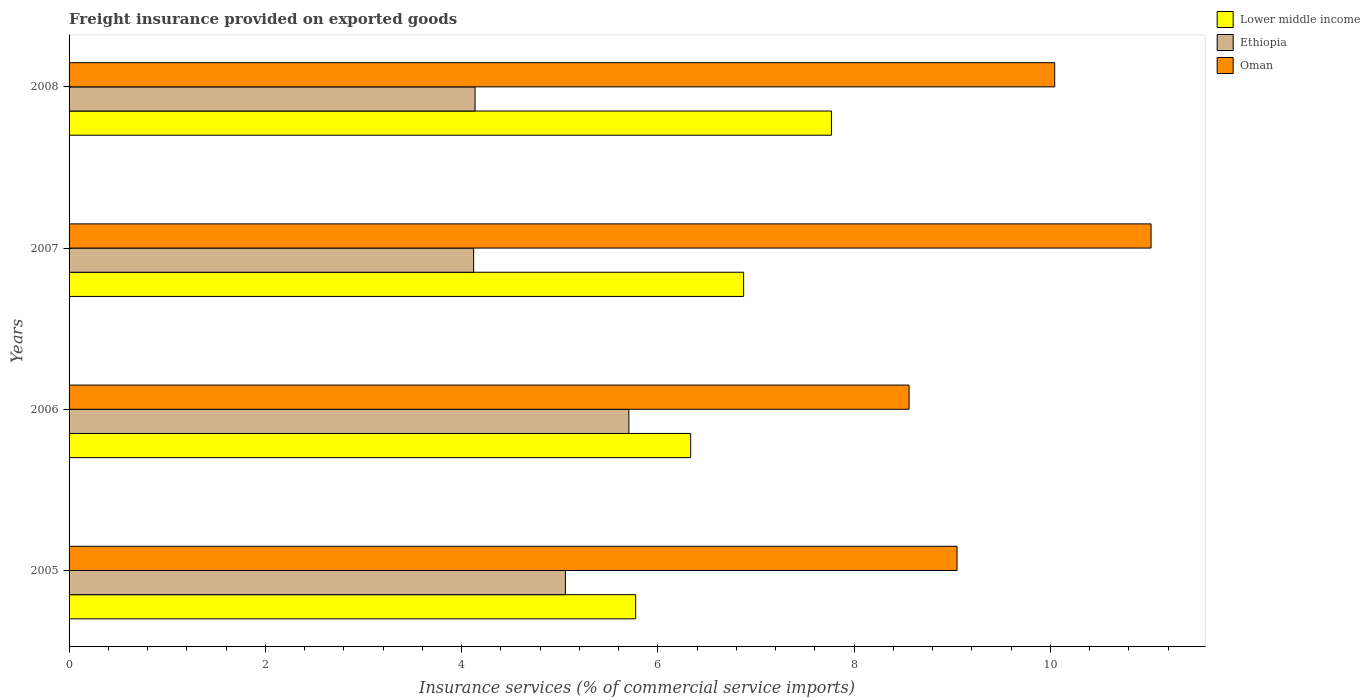Are the number of bars per tick equal to the number of legend labels?
Your answer should be compact. Yes. Are the number of bars on each tick of the Y-axis equal?
Ensure brevity in your answer.  Yes. How many bars are there on the 2nd tick from the top?
Ensure brevity in your answer.  3. What is the label of the 3rd group of bars from the top?
Provide a short and direct response. 2006. What is the freight insurance provided on exported goods in Lower middle income in 2007?
Make the answer very short. 6.87. Across all years, what is the maximum freight insurance provided on exported goods in Ethiopia?
Your response must be concise. 5.7. Across all years, what is the minimum freight insurance provided on exported goods in Ethiopia?
Offer a very short reply. 4.12. What is the total freight insurance provided on exported goods in Lower middle income in the graph?
Give a very brief answer. 26.75. What is the difference between the freight insurance provided on exported goods in Lower middle income in 2006 and that in 2007?
Provide a succinct answer. -0.54. What is the difference between the freight insurance provided on exported goods in Ethiopia in 2006 and the freight insurance provided on exported goods in Lower middle income in 2008?
Offer a terse response. -2.06. What is the average freight insurance provided on exported goods in Oman per year?
Provide a succinct answer. 9.67. In the year 2007, what is the difference between the freight insurance provided on exported goods in Ethiopia and freight insurance provided on exported goods in Oman?
Give a very brief answer. -6.9. What is the ratio of the freight insurance provided on exported goods in Ethiopia in 2007 to that in 2008?
Ensure brevity in your answer.  1. What is the difference between the highest and the second highest freight insurance provided on exported goods in Lower middle income?
Offer a terse response. 0.9. What is the difference between the highest and the lowest freight insurance provided on exported goods in Ethiopia?
Offer a very short reply. 1.58. In how many years, is the freight insurance provided on exported goods in Oman greater than the average freight insurance provided on exported goods in Oman taken over all years?
Keep it short and to the point. 2. What does the 3rd bar from the top in 2008 represents?
Offer a very short reply. Lower middle income. What does the 1st bar from the bottom in 2006 represents?
Give a very brief answer. Lower middle income. How many bars are there?
Give a very brief answer. 12. Are all the bars in the graph horizontal?
Offer a very short reply. Yes. What is the difference between two consecutive major ticks on the X-axis?
Keep it short and to the point. 2. Where does the legend appear in the graph?
Offer a terse response. Top right. How are the legend labels stacked?
Provide a succinct answer. Vertical. What is the title of the graph?
Offer a terse response. Freight insurance provided on exported goods. What is the label or title of the X-axis?
Offer a very short reply. Insurance services (% of commercial service imports). What is the Insurance services (% of commercial service imports) in Lower middle income in 2005?
Keep it short and to the point. 5.77. What is the Insurance services (% of commercial service imports) in Ethiopia in 2005?
Your answer should be compact. 5.06. What is the Insurance services (% of commercial service imports) in Oman in 2005?
Your response must be concise. 9.05. What is the Insurance services (% of commercial service imports) in Lower middle income in 2006?
Your response must be concise. 6.33. What is the Insurance services (% of commercial service imports) in Ethiopia in 2006?
Your response must be concise. 5.7. What is the Insurance services (% of commercial service imports) in Oman in 2006?
Offer a very short reply. 8.56. What is the Insurance services (% of commercial service imports) of Lower middle income in 2007?
Give a very brief answer. 6.87. What is the Insurance services (% of commercial service imports) of Ethiopia in 2007?
Your answer should be very brief. 4.12. What is the Insurance services (% of commercial service imports) of Oman in 2007?
Offer a terse response. 11.03. What is the Insurance services (% of commercial service imports) of Lower middle income in 2008?
Make the answer very short. 7.77. What is the Insurance services (% of commercial service imports) of Ethiopia in 2008?
Your answer should be very brief. 4.14. What is the Insurance services (% of commercial service imports) of Oman in 2008?
Offer a terse response. 10.04. Across all years, what is the maximum Insurance services (% of commercial service imports) in Lower middle income?
Offer a terse response. 7.77. Across all years, what is the maximum Insurance services (% of commercial service imports) in Ethiopia?
Your answer should be very brief. 5.7. Across all years, what is the maximum Insurance services (% of commercial service imports) of Oman?
Offer a very short reply. 11.03. Across all years, what is the minimum Insurance services (% of commercial service imports) of Lower middle income?
Give a very brief answer. 5.77. Across all years, what is the minimum Insurance services (% of commercial service imports) in Ethiopia?
Offer a terse response. 4.12. Across all years, what is the minimum Insurance services (% of commercial service imports) of Oman?
Provide a short and direct response. 8.56. What is the total Insurance services (% of commercial service imports) in Lower middle income in the graph?
Your answer should be very brief. 26.75. What is the total Insurance services (% of commercial service imports) in Ethiopia in the graph?
Your answer should be very brief. 19.02. What is the total Insurance services (% of commercial service imports) in Oman in the graph?
Provide a succinct answer. 38.68. What is the difference between the Insurance services (% of commercial service imports) of Lower middle income in 2005 and that in 2006?
Make the answer very short. -0.56. What is the difference between the Insurance services (% of commercial service imports) of Ethiopia in 2005 and that in 2006?
Your answer should be very brief. -0.65. What is the difference between the Insurance services (% of commercial service imports) in Oman in 2005 and that in 2006?
Your response must be concise. 0.49. What is the difference between the Insurance services (% of commercial service imports) of Lower middle income in 2005 and that in 2007?
Your answer should be compact. -1.1. What is the difference between the Insurance services (% of commercial service imports) in Ethiopia in 2005 and that in 2007?
Make the answer very short. 0.94. What is the difference between the Insurance services (% of commercial service imports) of Oman in 2005 and that in 2007?
Provide a succinct answer. -1.98. What is the difference between the Insurance services (% of commercial service imports) in Lower middle income in 2005 and that in 2008?
Provide a short and direct response. -2. What is the difference between the Insurance services (% of commercial service imports) of Ethiopia in 2005 and that in 2008?
Provide a succinct answer. 0.92. What is the difference between the Insurance services (% of commercial service imports) of Oman in 2005 and that in 2008?
Give a very brief answer. -1. What is the difference between the Insurance services (% of commercial service imports) of Lower middle income in 2006 and that in 2007?
Provide a short and direct response. -0.54. What is the difference between the Insurance services (% of commercial service imports) in Ethiopia in 2006 and that in 2007?
Give a very brief answer. 1.58. What is the difference between the Insurance services (% of commercial service imports) in Oman in 2006 and that in 2007?
Offer a terse response. -2.47. What is the difference between the Insurance services (% of commercial service imports) of Lower middle income in 2006 and that in 2008?
Offer a terse response. -1.43. What is the difference between the Insurance services (% of commercial service imports) in Ethiopia in 2006 and that in 2008?
Make the answer very short. 1.57. What is the difference between the Insurance services (% of commercial service imports) of Oman in 2006 and that in 2008?
Offer a terse response. -1.48. What is the difference between the Insurance services (% of commercial service imports) of Lower middle income in 2007 and that in 2008?
Provide a short and direct response. -0.9. What is the difference between the Insurance services (% of commercial service imports) of Ethiopia in 2007 and that in 2008?
Provide a succinct answer. -0.01. What is the difference between the Insurance services (% of commercial service imports) of Oman in 2007 and that in 2008?
Offer a terse response. 0.98. What is the difference between the Insurance services (% of commercial service imports) in Lower middle income in 2005 and the Insurance services (% of commercial service imports) in Ethiopia in 2006?
Keep it short and to the point. 0.07. What is the difference between the Insurance services (% of commercial service imports) of Lower middle income in 2005 and the Insurance services (% of commercial service imports) of Oman in 2006?
Your response must be concise. -2.79. What is the difference between the Insurance services (% of commercial service imports) of Ethiopia in 2005 and the Insurance services (% of commercial service imports) of Oman in 2006?
Offer a very short reply. -3.5. What is the difference between the Insurance services (% of commercial service imports) of Lower middle income in 2005 and the Insurance services (% of commercial service imports) of Ethiopia in 2007?
Make the answer very short. 1.65. What is the difference between the Insurance services (% of commercial service imports) in Lower middle income in 2005 and the Insurance services (% of commercial service imports) in Oman in 2007?
Your response must be concise. -5.25. What is the difference between the Insurance services (% of commercial service imports) of Ethiopia in 2005 and the Insurance services (% of commercial service imports) of Oman in 2007?
Your answer should be very brief. -5.97. What is the difference between the Insurance services (% of commercial service imports) of Lower middle income in 2005 and the Insurance services (% of commercial service imports) of Ethiopia in 2008?
Ensure brevity in your answer.  1.64. What is the difference between the Insurance services (% of commercial service imports) of Lower middle income in 2005 and the Insurance services (% of commercial service imports) of Oman in 2008?
Offer a very short reply. -4.27. What is the difference between the Insurance services (% of commercial service imports) in Ethiopia in 2005 and the Insurance services (% of commercial service imports) in Oman in 2008?
Offer a very short reply. -4.99. What is the difference between the Insurance services (% of commercial service imports) in Lower middle income in 2006 and the Insurance services (% of commercial service imports) in Ethiopia in 2007?
Make the answer very short. 2.21. What is the difference between the Insurance services (% of commercial service imports) in Lower middle income in 2006 and the Insurance services (% of commercial service imports) in Oman in 2007?
Give a very brief answer. -4.69. What is the difference between the Insurance services (% of commercial service imports) in Ethiopia in 2006 and the Insurance services (% of commercial service imports) in Oman in 2007?
Your response must be concise. -5.32. What is the difference between the Insurance services (% of commercial service imports) of Lower middle income in 2006 and the Insurance services (% of commercial service imports) of Ethiopia in 2008?
Give a very brief answer. 2.2. What is the difference between the Insurance services (% of commercial service imports) in Lower middle income in 2006 and the Insurance services (% of commercial service imports) in Oman in 2008?
Offer a terse response. -3.71. What is the difference between the Insurance services (% of commercial service imports) in Ethiopia in 2006 and the Insurance services (% of commercial service imports) in Oman in 2008?
Your answer should be very brief. -4.34. What is the difference between the Insurance services (% of commercial service imports) in Lower middle income in 2007 and the Insurance services (% of commercial service imports) in Ethiopia in 2008?
Offer a very short reply. 2.74. What is the difference between the Insurance services (% of commercial service imports) in Lower middle income in 2007 and the Insurance services (% of commercial service imports) in Oman in 2008?
Offer a very short reply. -3.17. What is the difference between the Insurance services (% of commercial service imports) in Ethiopia in 2007 and the Insurance services (% of commercial service imports) in Oman in 2008?
Your answer should be very brief. -5.92. What is the average Insurance services (% of commercial service imports) of Lower middle income per year?
Your response must be concise. 6.69. What is the average Insurance services (% of commercial service imports) of Ethiopia per year?
Offer a terse response. 4.76. What is the average Insurance services (% of commercial service imports) in Oman per year?
Your answer should be very brief. 9.67. In the year 2005, what is the difference between the Insurance services (% of commercial service imports) in Lower middle income and Insurance services (% of commercial service imports) in Ethiopia?
Provide a succinct answer. 0.72. In the year 2005, what is the difference between the Insurance services (% of commercial service imports) of Lower middle income and Insurance services (% of commercial service imports) of Oman?
Offer a very short reply. -3.27. In the year 2005, what is the difference between the Insurance services (% of commercial service imports) of Ethiopia and Insurance services (% of commercial service imports) of Oman?
Keep it short and to the point. -3.99. In the year 2006, what is the difference between the Insurance services (% of commercial service imports) of Lower middle income and Insurance services (% of commercial service imports) of Ethiopia?
Your answer should be very brief. 0.63. In the year 2006, what is the difference between the Insurance services (% of commercial service imports) in Lower middle income and Insurance services (% of commercial service imports) in Oman?
Keep it short and to the point. -2.23. In the year 2006, what is the difference between the Insurance services (% of commercial service imports) of Ethiopia and Insurance services (% of commercial service imports) of Oman?
Make the answer very short. -2.86. In the year 2007, what is the difference between the Insurance services (% of commercial service imports) of Lower middle income and Insurance services (% of commercial service imports) of Ethiopia?
Your answer should be very brief. 2.75. In the year 2007, what is the difference between the Insurance services (% of commercial service imports) of Lower middle income and Insurance services (% of commercial service imports) of Oman?
Offer a very short reply. -4.15. In the year 2007, what is the difference between the Insurance services (% of commercial service imports) of Ethiopia and Insurance services (% of commercial service imports) of Oman?
Provide a short and direct response. -6.9. In the year 2008, what is the difference between the Insurance services (% of commercial service imports) of Lower middle income and Insurance services (% of commercial service imports) of Ethiopia?
Keep it short and to the point. 3.63. In the year 2008, what is the difference between the Insurance services (% of commercial service imports) in Lower middle income and Insurance services (% of commercial service imports) in Oman?
Offer a very short reply. -2.28. In the year 2008, what is the difference between the Insurance services (% of commercial service imports) of Ethiopia and Insurance services (% of commercial service imports) of Oman?
Offer a very short reply. -5.91. What is the ratio of the Insurance services (% of commercial service imports) in Lower middle income in 2005 to that in 2006?
Your response must be concise. 0.91. What is the ratio of the Insurance services (% of commercial service imports) of Ethiopia in 2005 to that in 2006?
Provide a short and direct response. 0.89. What is the ratio of the Insurance services (% of commercial service imports) of Oman in 2005 to that in 2006?
Provide a short and direct response. 1.06. What is the ratio of the Insurance services (% of commercial service imports) in Lower middle income in 2005 to that in 2007?
Ensure brevity in your answer.  0.84. What is the ratio of the Insurance services (% of commercial service imports) of Ethiopia in 2005 to that in 2007?
Offer a very short reply. 1.23. What is the ratio of the Insurance services (% of commercial service imports) of Oman in 2005 to that in 2007?
Provide a short and direct response. 0.82. What is the ratio of the Insurance services (% of commercial service imports) in Lower middle income in 2005 to that in 2008?
Your answer should be compact. 0.74. What is the ratio of the Insurance services (% of commercial service imports) of Ethiopia in 2005 to that in 2008?
Ensure brevity in your answer.  1.22. What is the ratio of the Insurance services (% of commercial service imports) in Oman in 2005 to that in 2008?
Keep it short and to the point. 0.9. What is the ratio of the Insurance services (% of commercial service imports) in Lower middle income in 2006 to that in 2007?
Your response must be concise. 0.92. What is the ratio of the Insurance services (% of commercial service imports) in Ethiopia in 2006 to that in 2007?
Give a very brief answer. 1.38. What is the ratio of the Insurance services (% of commercial service imports) in Oman in 2006 to that in 2007?
Provide a succinct answer. 0.78. What is the ratio of the Insurance services (% of commercial service imports) of Lower middle income in 2006 to that in 2008?
Your response must be concise. 0.82. What is the ratio of the Insurance services (% of commercial service imports) in Ethiopia in 2006 to that in 2008?
Give a very brief answer. 1.38. What is the ratio of the Insurance services (% of commercial service imports) in Oman in 2006 to that in 2008?
Keep it short and to the point. 0.85. What is the ratio of the Insurance services (% of commercial service imports) of Lower middle income in 2007 to that in 2008?
Make the answer very short. 0.88. What is the ratio of the Insurance services (% of commercial service imports) of Ethiopia in 2007 to that in 2008?
Offer a very short reply. 1. What is the ratio of the Insurance services (% of commercial service imports) in Oman in 2007 to that in 2008?
Keep it short and to the point. 1.1. What is the difference between the highest and the second highest Insurance services (% of commercial service imports) in Lower middle income?
Offer a very short reply. 0.9. What is the difference between the highest and the second highest Insurance services (% of commercial service imports) in Ethiopia?
Make the answer very short. 0.65. What is the difference between the highest and the second highest Insurance services (% of commercial service imports) in Oman?
Provide a short and direct response. 0.98. What is the difference between the highest and the lowest Insurance services (% of commercial service imports) in Lower middle income?
Your answer should be very brief. 2. What is the difference between the highest and the lowest Insurance services (% of commercial service imports) of Ethiopia?
Ensure brevity in your answer.  1.58. What is the difference between the highest and the lowest Insurance services (% of commercial service imports) of Oman?
Provide a short and direct response. 2.47. 